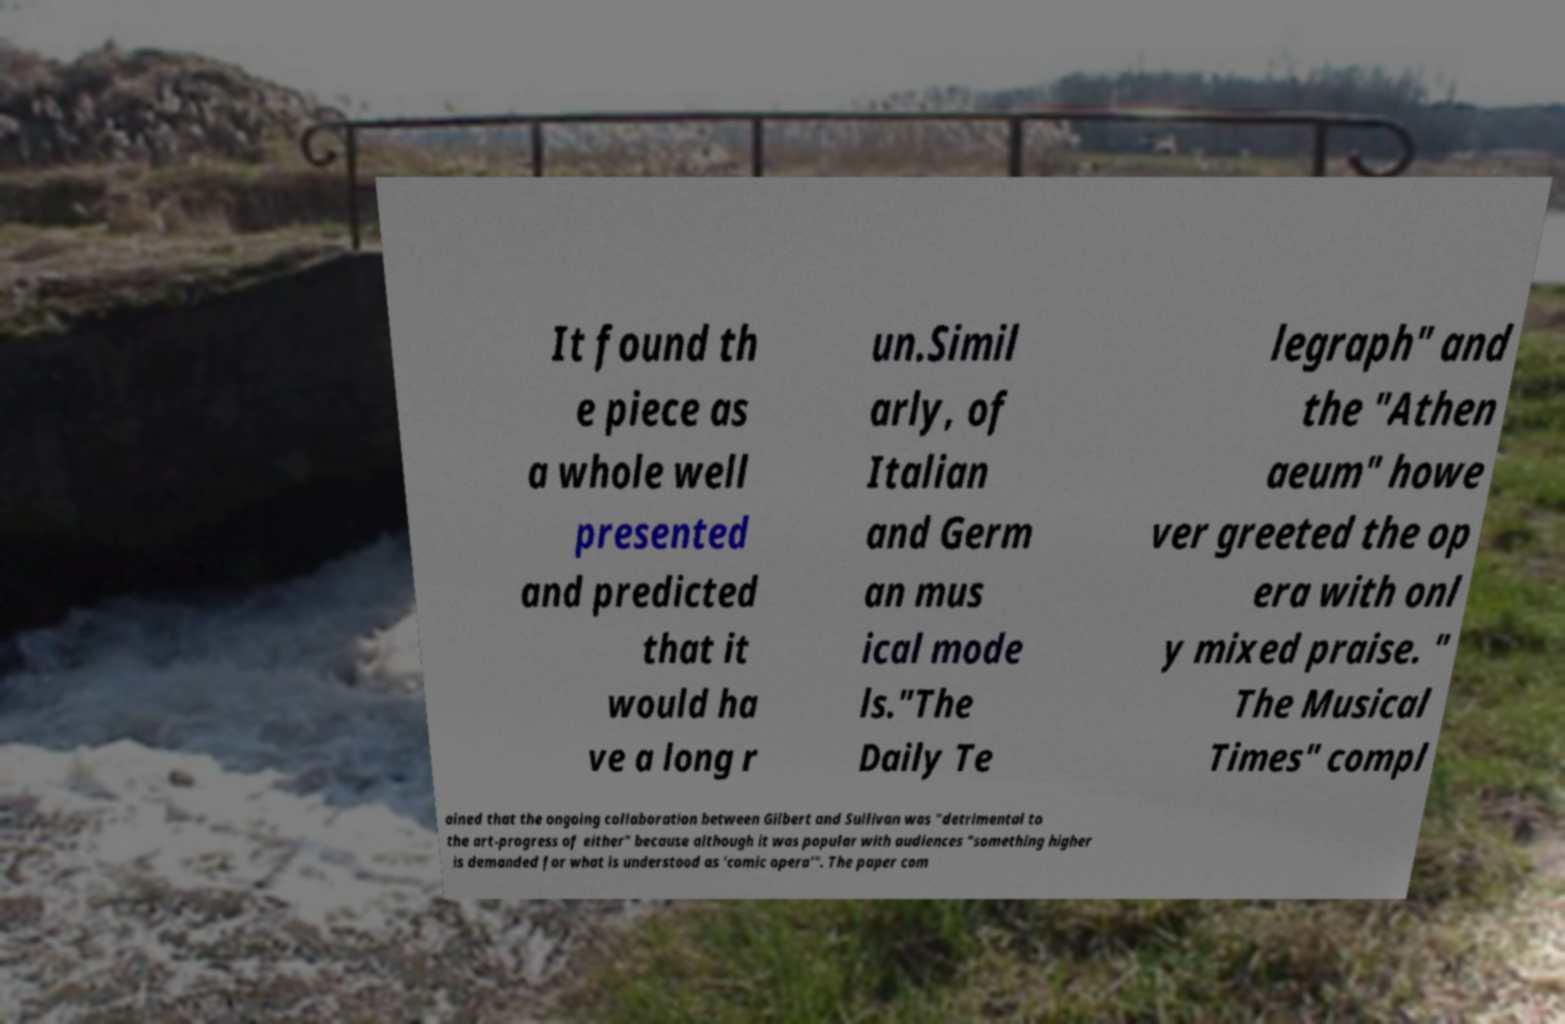Could you assist in decoding the text presented in this image and type it out clearly? It found th e piece as a whole well presented and predicted that it would ha ve a long r un.Simil arly, of Italian and Germ an mus ical mode ls."The Daily Te legraph" and the "Athen aeum" howe ver greeted the op era with onl y mixed praise. " The Musical Times" compl ained that the ongoing collaboration between Gilbert and Sullivan was "detrimental to the art-progress of either" because although it was popular with audiences "something higher is demanded for what is understood as 'comic opera'". The paper com 